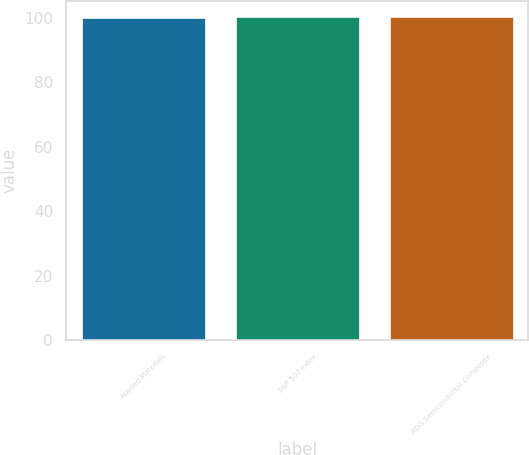Convert chart to OTSL. <chart><loc_0><loc_0><loc_500><loc_500><bar_chart><fcel>Applied Materials<fcel>S&P 500 Index<fcel>RDG Semiconductor Composite<nl><fcel>100<fcel>100.1<fcel>100.2<nl></chart> 